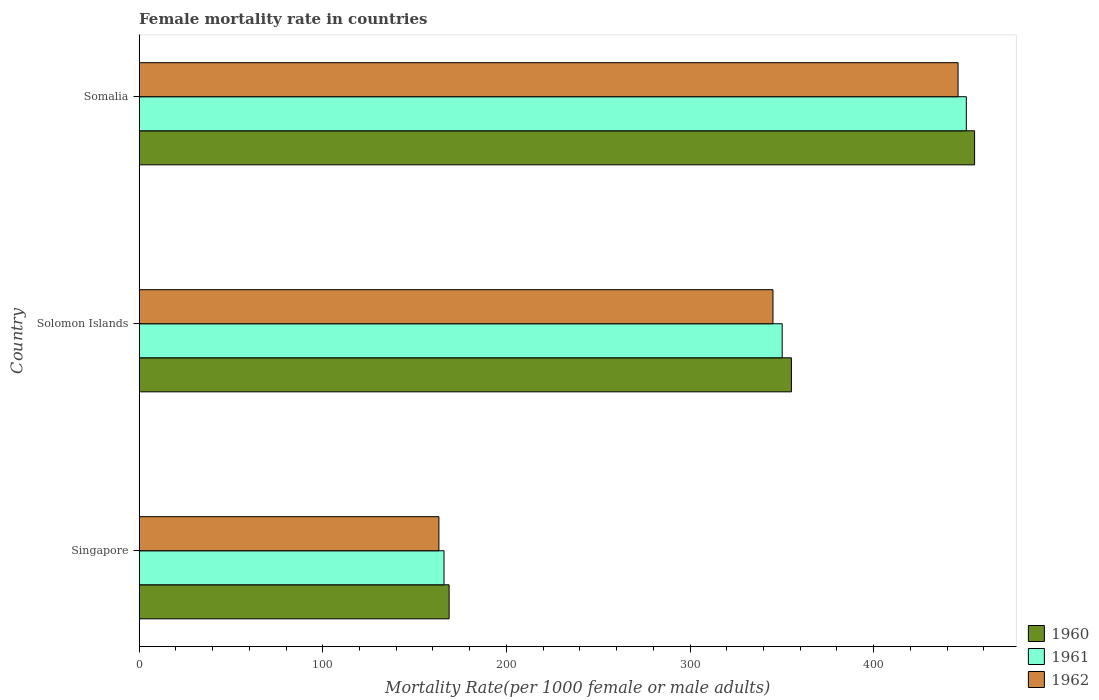How many different coloured bars are there?
Make the answer very short. 3. Are the number of bars per tick equal to the number of legend labels?
Offer a terse response. Yes. Are the number of bars on each tick of the Y-axis equal?
Your response must be concise. Yes. How many bars are there on the 1st tick from the bottom?
Provide a succinct answer. 3. What is the label of the 3rd group of bars from the top?
Offer a terse response. Singapore. What is the female mortality rate in 1961 in Somalia?
Give a very brief answer. 450.5. Across all countries, what is the maximum female mortality rate in 1961?
Provide a short and direct response. 450.5. Across all countries, what is the minimum female mortality rate in 1960?
Provide a succinct answer. 168.82. In which country was the female mortality rate in 1961 maximum?
Your response must be concise. Somalia. In which country was the female mortality rate in 1961 minimum?
Your response must be concise. Singapore. What is the total female mortality rate in 1961 in the graph?
Make the answer very short. 966.74. What is the difference between the female mortality rate in 1961 in Singapore and that in Solomon Islands?
Provide a short and direct response. -184.18. What is the difference between the female mortality rate in 1960 in Solomon Islands and the female mortality rate in 1962 in Somalia?
Provide a short and direct response. -90.77. What is the average female mortality rate in 1961 per country?
Give a very brief answer. 322.25. What is the difference between the female mortality rate in 1962 and female mortality rate in 1960 in Somalia?
Provide a short and direct response. -9. In how many countries, is the female mortality rate in 1960 greater than 220 ?
Your answer should be compact. 2. What is the ratio of the female mortality rate in 1961 in Singapore to that in Solomon Islands?
Make the answer very short. 0.47. What is the difference between the highest and the second highest female mortality rate in 1961?
Make the answer very short. 100.29. What is the difference between the highest and the lowest female mortality rate in 1960?
Give a very brief answer. 286.18. How many bars are there?
Keep it short and to the point. 9. How many countries are there in the graph?
Provide a succinct answer. 3. What is the difference between two consecutive major ticks on the X-axis?
Your response must be concise. 100. Does the graph contain any zero values?
Offer a terse response. No. Where does the legend appear in the graph?
Keep it short and to the point. Bottom right. What is the title of the graph?
Offer a terse response. Female mortality rate in countries. Does "1991" appear as one of the legend labels in the graph?
Offer a very short reply. No. What is the label or title of the X-axis?
Your answer should be compact. Mortality Rate(per 1000 female or male adults). What is the label or title of the Y-axis?
Give a very brief answer. Country. What is the Mortality Rate(per 1000 female or male adults) in 1960 in Singapore?
Offer a terse response. 168.82. What is the Mortality Rate(per 1000 female or male adults) of 1961 in Singapore?
Offer a terse response. 166.03. What is the Mortality Rate(per 1000 female or male adults) of 1962 in Singapore?
Your response must be concise. 163.25. What is the Mortality Rate(per 1000 female or male adults) of 1960 in Solomon Islands?
Provide a short and direct response. 355.23. What is the Mortality Rate(per 1000 female or male adults) of 1961 in Solomon Islands?
Keep it short and to the point. 350.21. What is the Mortality Rate(per 1000 female or male adults) of 1962 in Solomon Islands?
Your response must be concise. 345.19. What is the Mortality Rate(per 1000 female or male adults) of 1960 in Somalia?
Your answer should be very brief. 455. What is the Mortality Rate(per 1000 female or male adults) of 1961 in Somalia?
Make the answer very short. 450.5. What is the Mortality Rate(per 1000 female or male adults) in 1962 in Somalia?
Provide a succinct answer. 446. Across all countries, what is the maximum Mortality Rate(per 1000 female or male adults) in 1960?
Provide a short and direct response. 455. Across all countries, what is the maximum Mortality Rate(per 1000 female or male adults) of 1961?
Offer a very short reply. 450.5. Across all countries, what is the maximum Mortality Rate(per 1000 female or male adults) of 1962?
Provide a short and direct response. 446. Across all countries, what is the minimum Mortality Rate(per 1000 female or male adults) of 1960?
Give a very brief answer. 168.82. Across all countries, what is the minimum Mortality Rate(per 1000 female or male adults) in 1961?
Your response must be concise. 166.03. Across all countries, what is the minimum Mortality Rate(per 1000 female or male adults) of 1962?
Provide a short and direct response. 163.25. What is the total Mortality Rate(per 1000 female or male adults) in 1960 in the graph?
Your answer should be very brief. 979.04. What is the total Mortality Rate(per 1000 female or male adults) in 1961 in the graph?
Offer a very short reply. 966.74. What is the total Mortality Rate(per 1000 female or male adults) in 1962 in the graph?
Provide a succinct answer. 954.43. What is the difference between the Mortality Rate(per 1000 female or male adults) in 1960 in Singapore and that in Solomon Islands?
Provide a succinct answer. -186.41. What is the difference between the Mortality Rate(per 1000 female or male adults) in 1961 in Singapore and that in Solomon Islands?
Provide a succinct answer. -184.18. What is the difference between the Mortality Rate(per 1000 female or male adults) of 1962 in Singapore and that in Solomon Islands?
Keep it short and to the point. -181.94. What is the difference between the Mortality Rate(per 1000 female or male adults) of 1960 in Singapore and that in Somalia?
Keep it short and to the point. -286.18. What is the difference between the Mortality Rate(per 1000 female or male adults) in 1961 in Singapore and that in Somalia?
Provide a short and direct response. -284.47. What is the difference between the Mortality Rate(per 1000 female or male adults) in 1962 in Singapore and that in Somalia?
Provide a succinct answer. -282.75. What is the difference between the Mortality Rate(per 1000 female or male adults) of 1960 in Solomon Islands and that in Somalia?
Offer a terse response. -99.77. What is the difference between the Mortality Rate(per 1000 female or male adults) in 1961 in Solomon Islands and that in Somalia?
Keep it short and to the point. -100.29. What is the difference between the Mortality Rate(per 1000 female or male adults) in 1962 in Solomon Islands and that in Somalia?
Provide a short and direct response. -100.81. What is the difference between the Mortality Rate(per 1000 female or male adults) in 1960 in Singapore and the Mortality Rate(per 1000 female or male adults) in 1961 in Solomon Islands?
Ensure brevity in your answer.  -181.39. What is the difference between the Mortality Rate(per 1000 female or male adults) in 1960 in Singapore and the Mortality Rate(per 1000 female or male adults) in 1962 in Solomon Islands?
Give a very brief answer. -176.37. What is the difference between the Mortality Rate(per 1000 female or male adults) in 1961 in Singapore and the Mortality Rate(per 1000 female or male adults) in 1962 in Solomon Islands?
Offer a terse response. -179.16. What is the difference between the Mortality Rate(per 1000 female or male adults) of 1960 in Singapore and the Mortality Rate(per 1000 female or male adults) of 1961 in Somalia?
Your response must be concise. -281.68. What is the difference between the Mortality Rate(per 1000 female or male adults) of 1960 in Singapore and the Mortality Rate(per 1000 female or male adults) of 1962 in Somalia?
Provide a short and direct response. -277.18. What is the difference between the Mortality Rate(per 1000 female or male adults) of 1961 in Singapore and the Mortality Rate(per 1000 female or male adults) of 1962 in Somalia?
Ensure brevity in your answer.  -279.96. What is the difference between the Mortality Rate(per 1000 female or male adults) in 1960 in Solomon Islands and the Mortality Rate(per 1000 female or male adults) in 1961 in Somalia?
Make the answer very short. -95.27. What is the difference between the Mortality Rate(per 1000 female or male adults) in 1960 in Solomon Islands and the Mortality Rate(per 1000 female or male adults) in 1962 in Somalia?
Your response must be concise. -90.77. What is the difference between the Mortality Rate(per 1000 female or male adults) of 1961 in Solomon Islands and the Mortality Rate(per 1000 female or male adults) of 1962 in Somalia?
Your response must be concise. -95.79. What is the average Mortality Rate(per 1000 female or male adults) in 1960 per country?
Make the answer very short. 326.35. What is the average Mortality Rate(per 1000 female or male adults) of 1961 per country?
Provide a short and direct response. 322.25. What is the average Mortality Rate(per 1000 female or male adults) of 1962 per country?
Your answer should be very brief. 318.14. What is the difference between the Mortality Rate(per 1000 female or male adults) in 1960 and Mortality Rate(per 1000 female or male adults) in 1961 in Singapore?
Give a very brief answer. 2.78. What is the difference between the Mortality Rate(per 1000 female or male adults) in 1960 and Mortality Rate(per 1000 female or male adults) in 1962 in Singapore?
Keep it short and to the point. 5.57. What is the difference between the Mortality Rate(per 1000 female or male adults) in 1961 and Mortality Rate(per 1000 female or male adults) in 1962 in Singapore?
Ensure brevity in your answer.  2.78. What is the difference between the Mortality Rate(per 1000 female or male adults) of 1960 and Mortality Rate(per 1000 female or male adults) of 1961 in Solomon Islands?
Ensure brevity in your answer.  5.02. What is the difference between the Mortality Rate(per 1000 female or male adults) of 1960 and Mortality Rate(per 1000 female or male adults) of 1962 in Solomon Islands?
Offer a terse response. 10.04. What is the difference between the Mortality Rate(per 1000 female or male adults) of 1961 and Mortality Rate(per 1000 female or male adults) of 1962 in Solomon Islands?
Give a very brief answer. 5.02. What is the difference between the Mortality Rate(per 1000 female or male adults) of 1960 and Mortality Rate(per 1000 female or male adults) of 1961 in Somalia?
Keep it short and to the point. 4.5. What is the difference between the Mortality Rate(per 1000 female or male adults) of 1960 and Mortality Rate(per 1000 female or male adults) of 1962 in Somalia?
Give a very brief answer. 9. What is the difference between the Mortality Rate(per 1000 female or male adults) of 1961 and Mortality Rate(per 1000 female or male adults) of 1962 in Somalia?
Offer a very short reply. 4.5. What is the ratio of the Mortality Rate(per 1000 female or male adults) of 1960 in Singapore to that in Solomon Islands?
Your answer should be very brief. 0.48. What is the ratio of the Mortality Rate(per 1000 female or male adults) of 1961 in Singapore to that in Solomon Islands?
Your response must be concise. 0.47. What is the ratio of the Mortality Rate(per 1000 female or male adults) of 1962 in Singapore to that in Solomon Islands?
Offer a very short reply. 0.47. What is the ratio of the Mortality Rate(per 1000 female or male adults) of 1960 in Singapore to that in Somalia?
Keep it short and to the point. 0.37. What is the ratio of the Mortality Rate(per 1000 female or male adults) of 1961 in Singapore to that in Somalia?
Give a very brief answer. 0.37. What is the ratio of the Mortality Rate(per 1000 female or male adults) of 1962 in Singapore to that in Somalia?
Give a very brief answer. 0.37. What is the ratio of the Mortality Rate(per 1000 female or male adults) of 1960 in Solomon Islands to that in Somalia?
Ensure brevity in your answer.  0.78. What is the ratio of the Mortality Rate(per 1000 female or male adults) of 1961 in Solomon Islands to that in Somalia?
Provide a short and direct response. 0.78. What is the ratio of the Mortality Rate(per 1000 female or male adults) of 1962 in Solomon Islands to that in Somalia?
Your answer should be compact. 0.77. What is the difference between the highest and the second highest Mortality Rate(per 1000 female or male adults) in 1960?
Provide a succinct answer. 99.77. What is the difference between the highest and the second highest Mortality Rate(per 1000 female or male adults) of 1961?
Keep it short and to the point. 100.29. What is the difference between the highest and the second highest Mortality Rate(per 1000 female or male adults) of 1962?
Offer a very short reply. 100.81. What is the difference between the highest and the lowest Mortality Rate(per 1000 female or male adults) in 1960?
Make the answer very short. 286.18. What is the difference between the highest and the lowest Mortality Rate(per 1000 female or male adults) of 1961?
Keep it short and to the point. 284.47. What is the difference between the highest and the lowest Mortality Rate(per 1000 female or male adults) of 1962?
Offer a terse response. 282.75. 